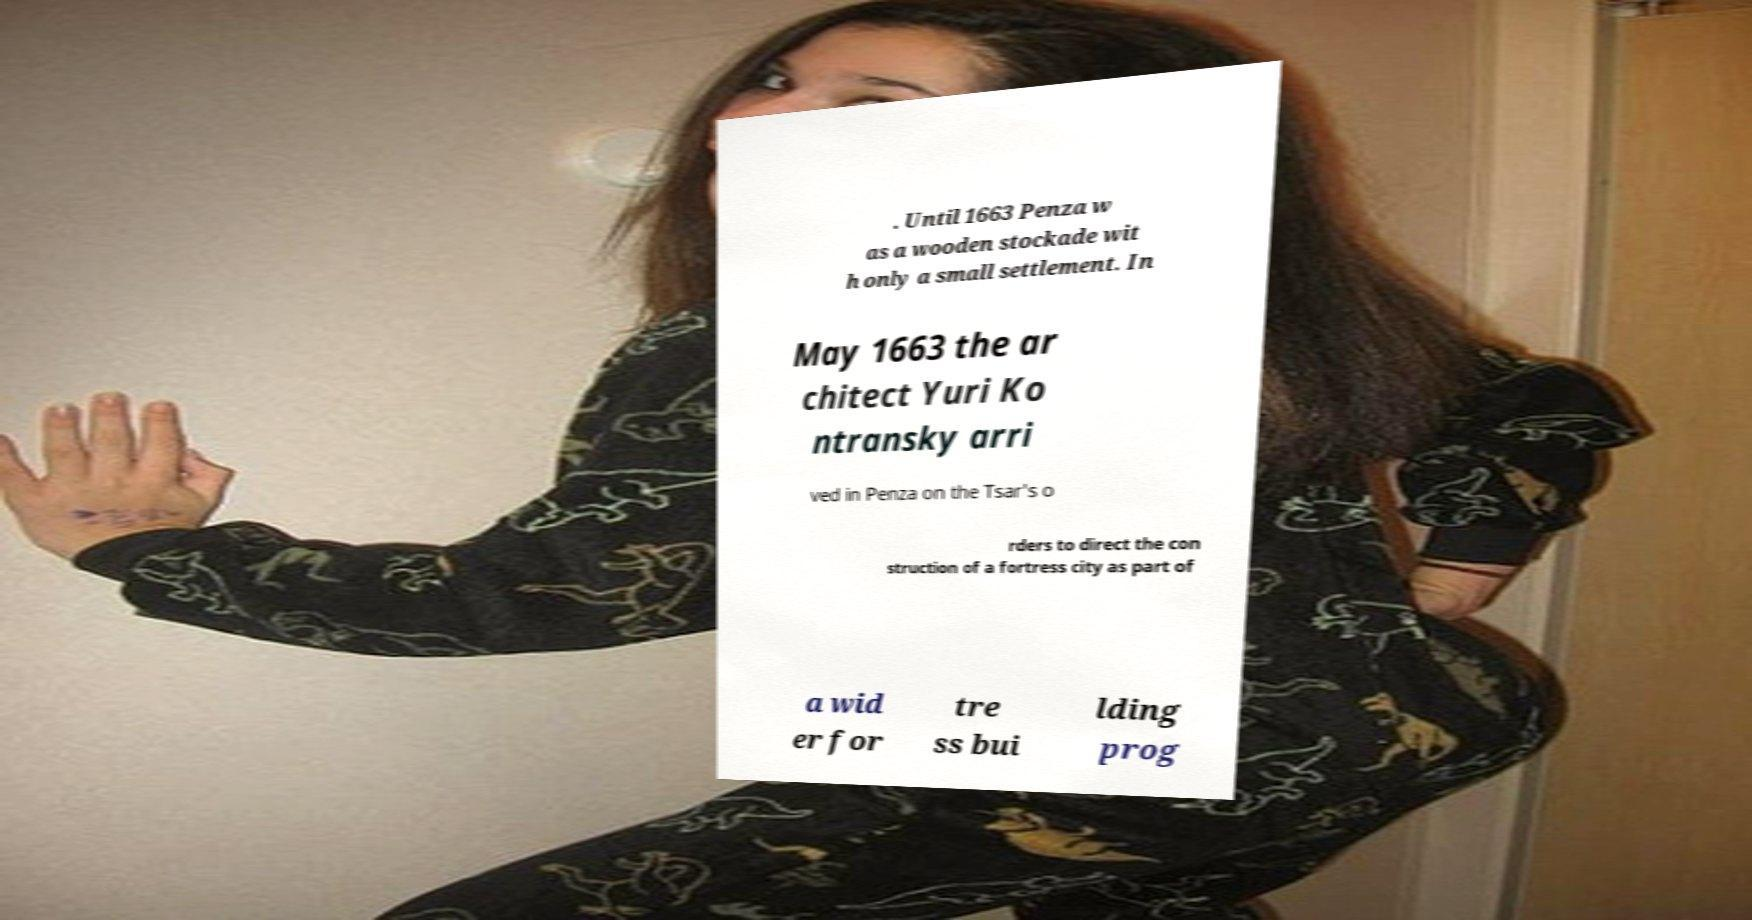Please read and relay the text visible in this image. What does it say? . Until 1663 Penza w as a wooden stockade wit h only a small settlement. In May 1663 the ar chitect Yuri Ko ntransky arri ved in Penza on the Tsar's o rders to direct the con struction of a fortress city as part of a wid er for tre ss bui lding prog 